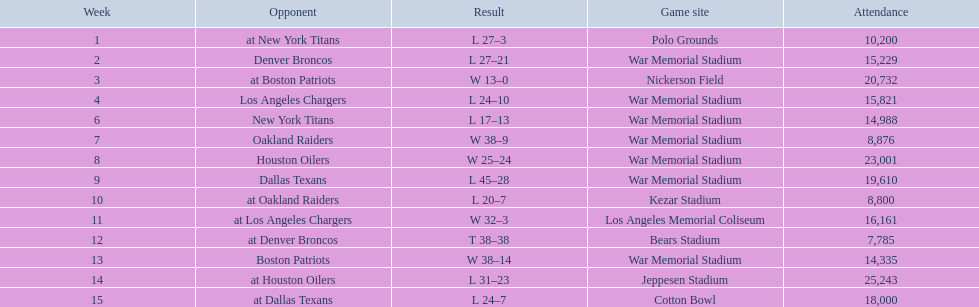What date was the first game at war memorial stadium? September 18, 1960. 